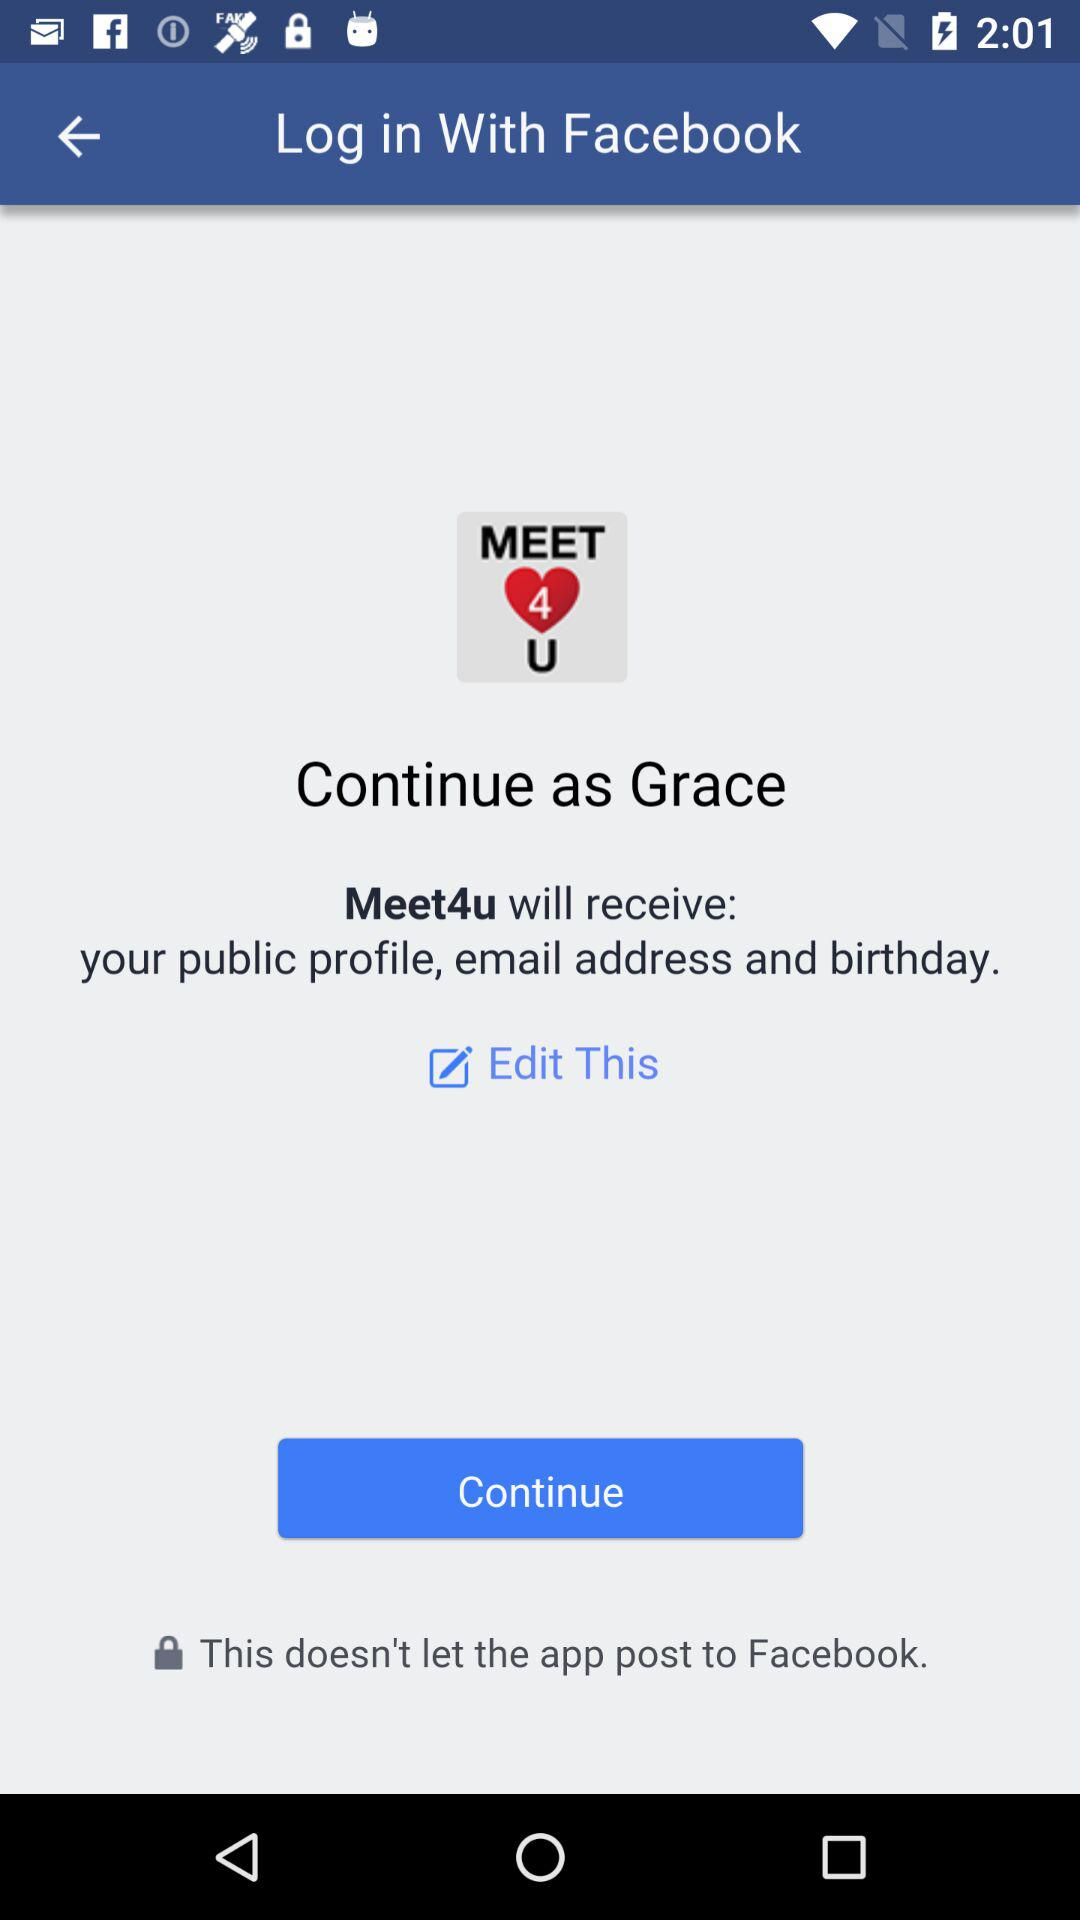What is the name of the user? The name of the user is Grace. 